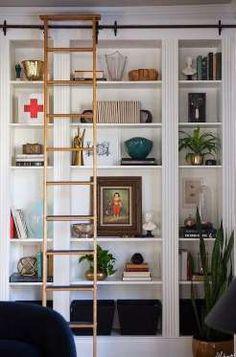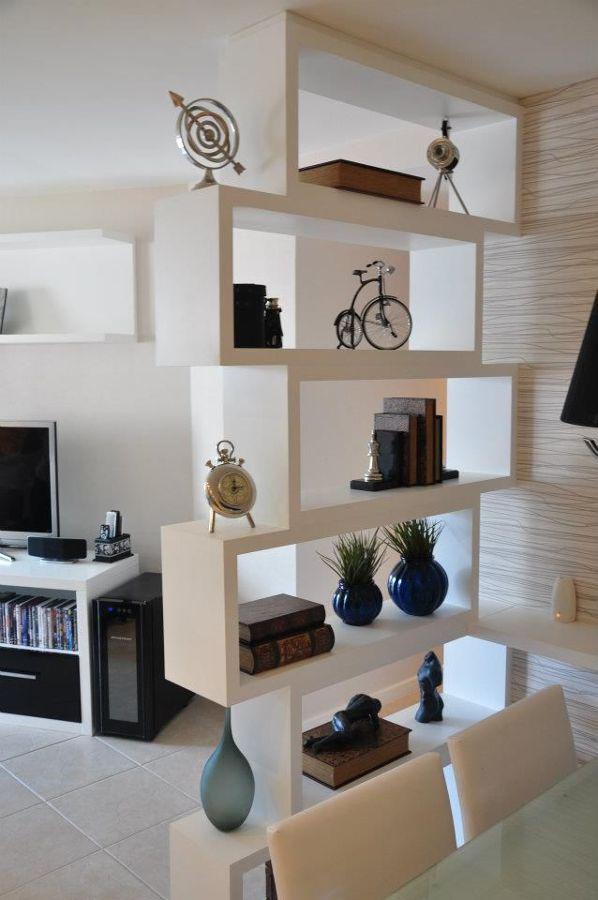The first image is the image on the left, the second image is the image on the right. Analyze the images presented: Is the assertion "In at least one image, a shelving unit is used as a room divider." valid? Answer yes or no. Yes. The first image is the image on the left, the second image is the image on the right. Assess this claim about the two images: "there is a chair in the image on the left". Correct or not? Answer yes or no. No. 